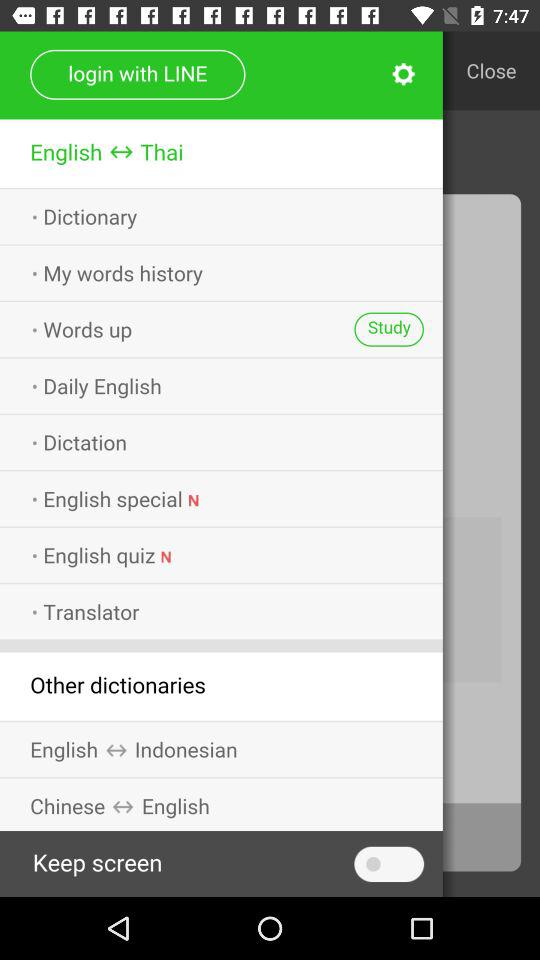What is the type of English dictionary?
When the provided information is insufficient, respond with <no answer>. <no answer> 